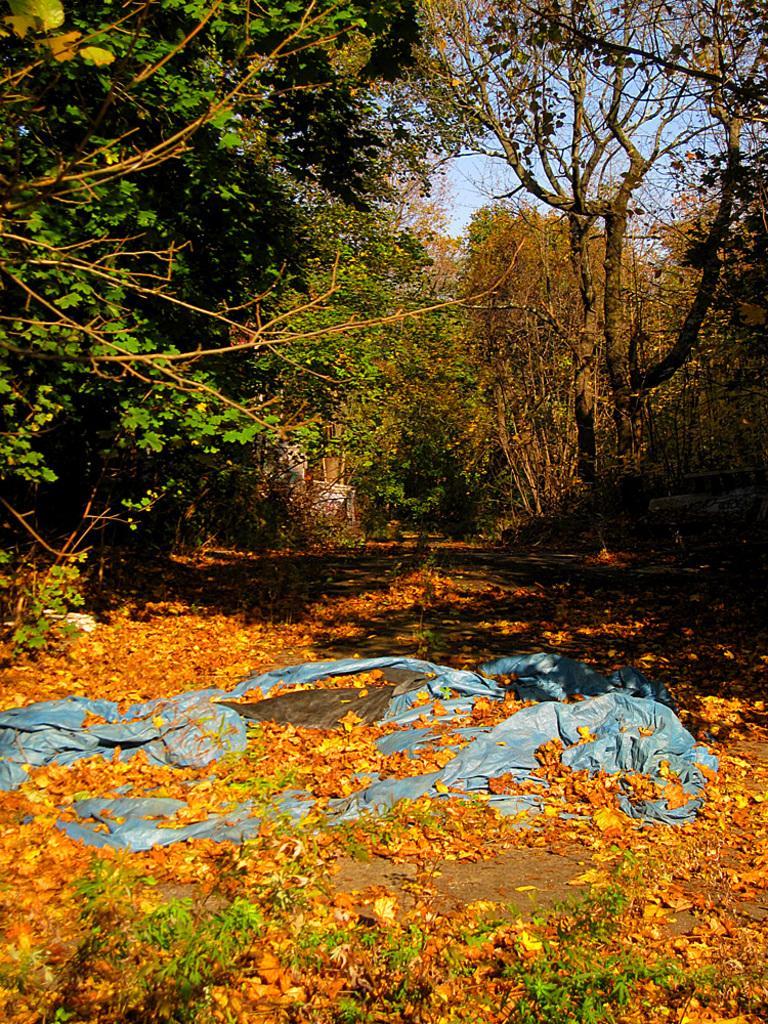Describe this image in one or two sentences. In this image in the background there are a group of trees, and at the bottom there are some dry leaves. 